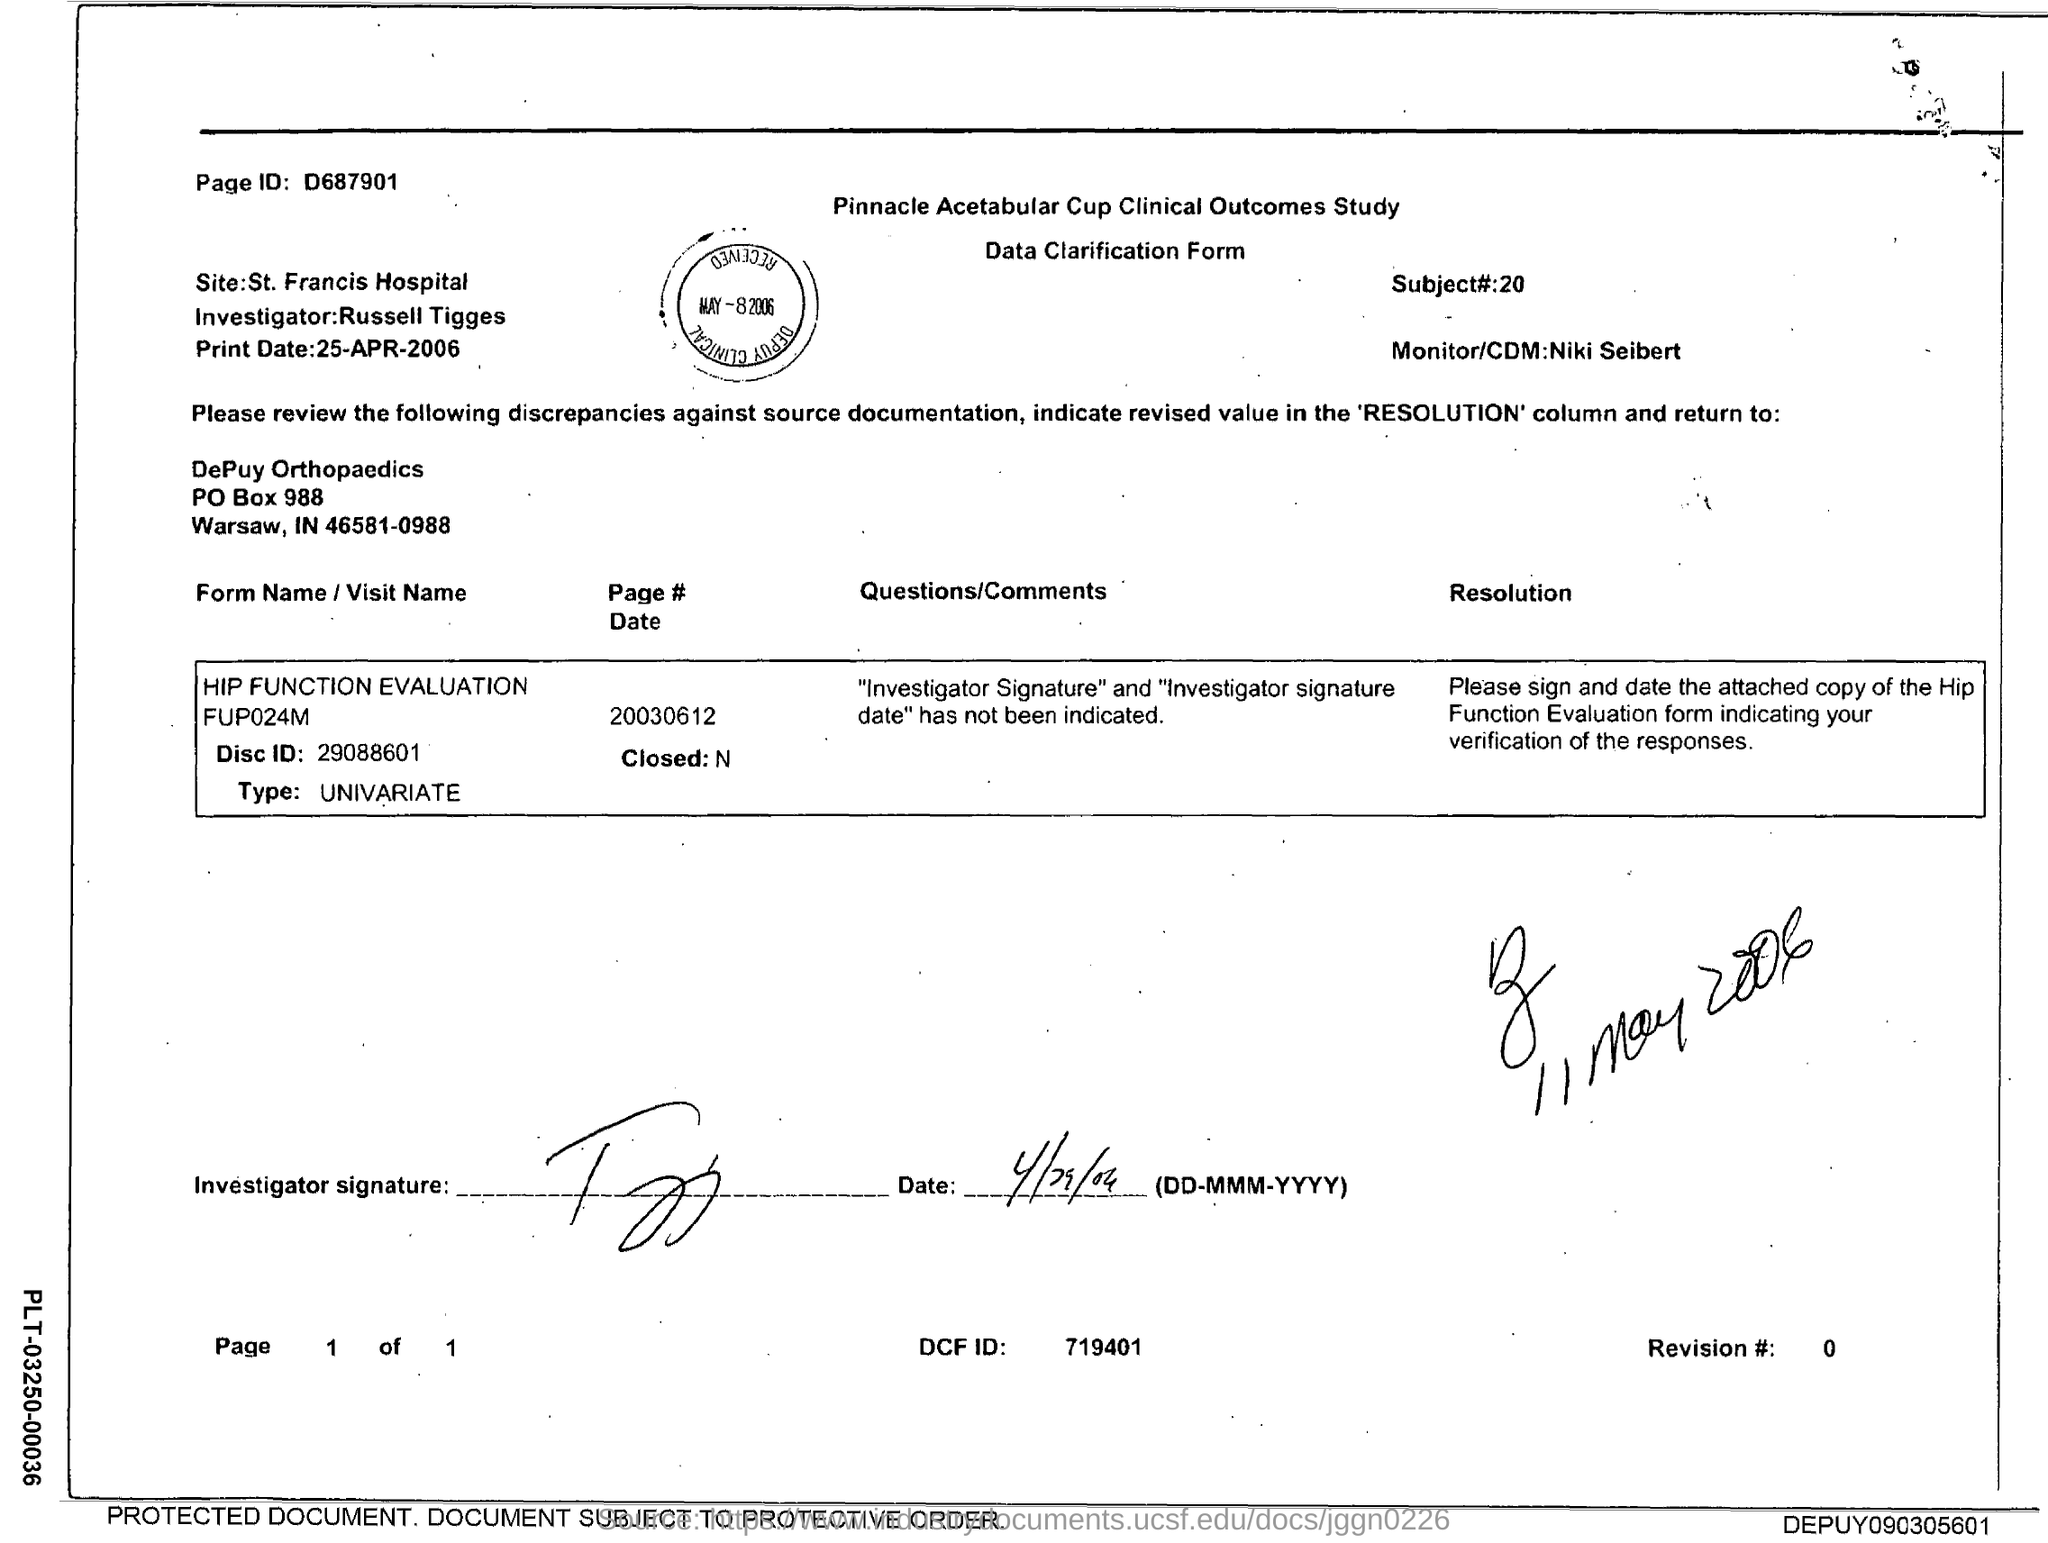Draw attention to some important aspects in this diagram. The Disc ID mentioned in the form is 29088601. It is Russell Tigges who is the investigator as per the form. The revision number mentioned in the form is 0.. The given form is a data clarification form. The subject mentioned in the form is 20.. 